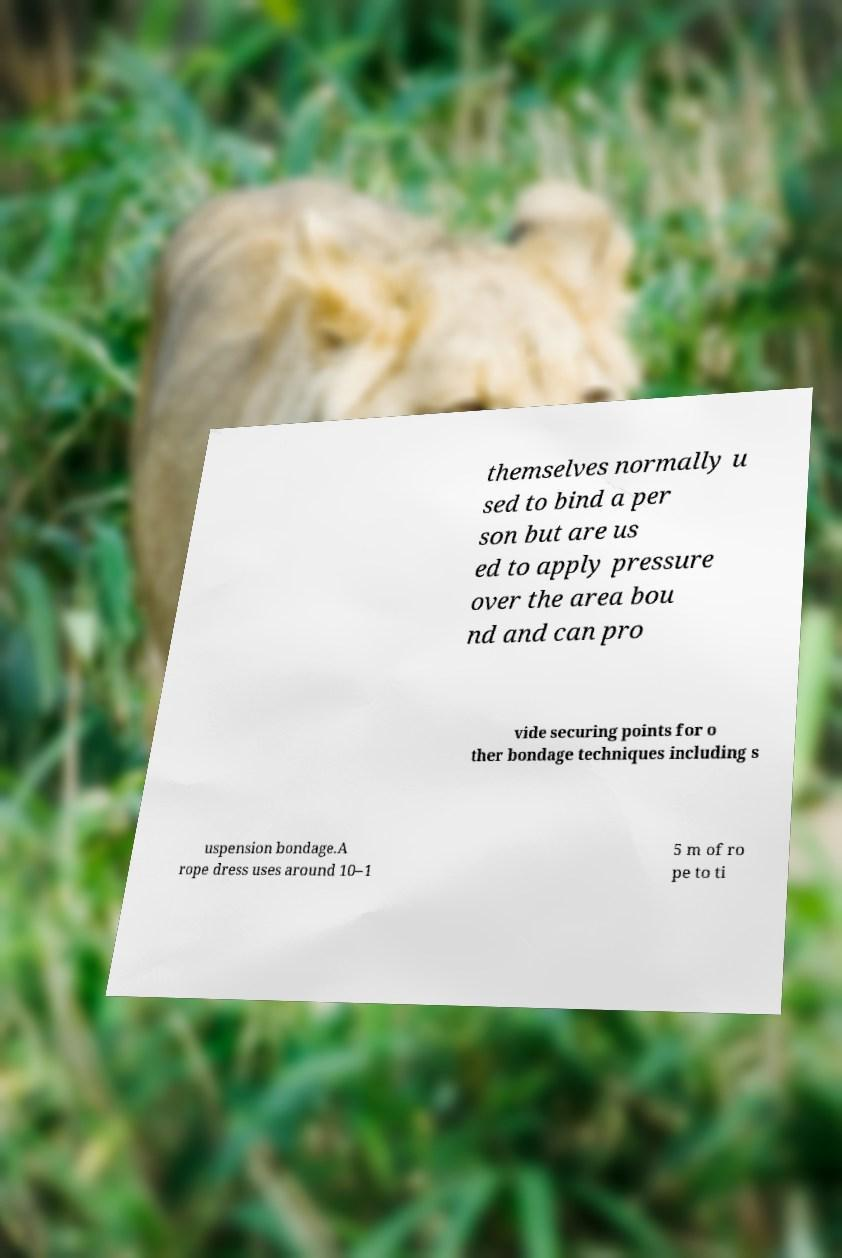Please read and relay the text visible in this image. What does it say? themselves normally u sed to bind a per son but are us ed to apply pressure over the area bou nd and can pro vide securing points for o ther bondage techniques including s uspension bondage.A rope dress uses around 10–1 5 m of ro pe to ti 